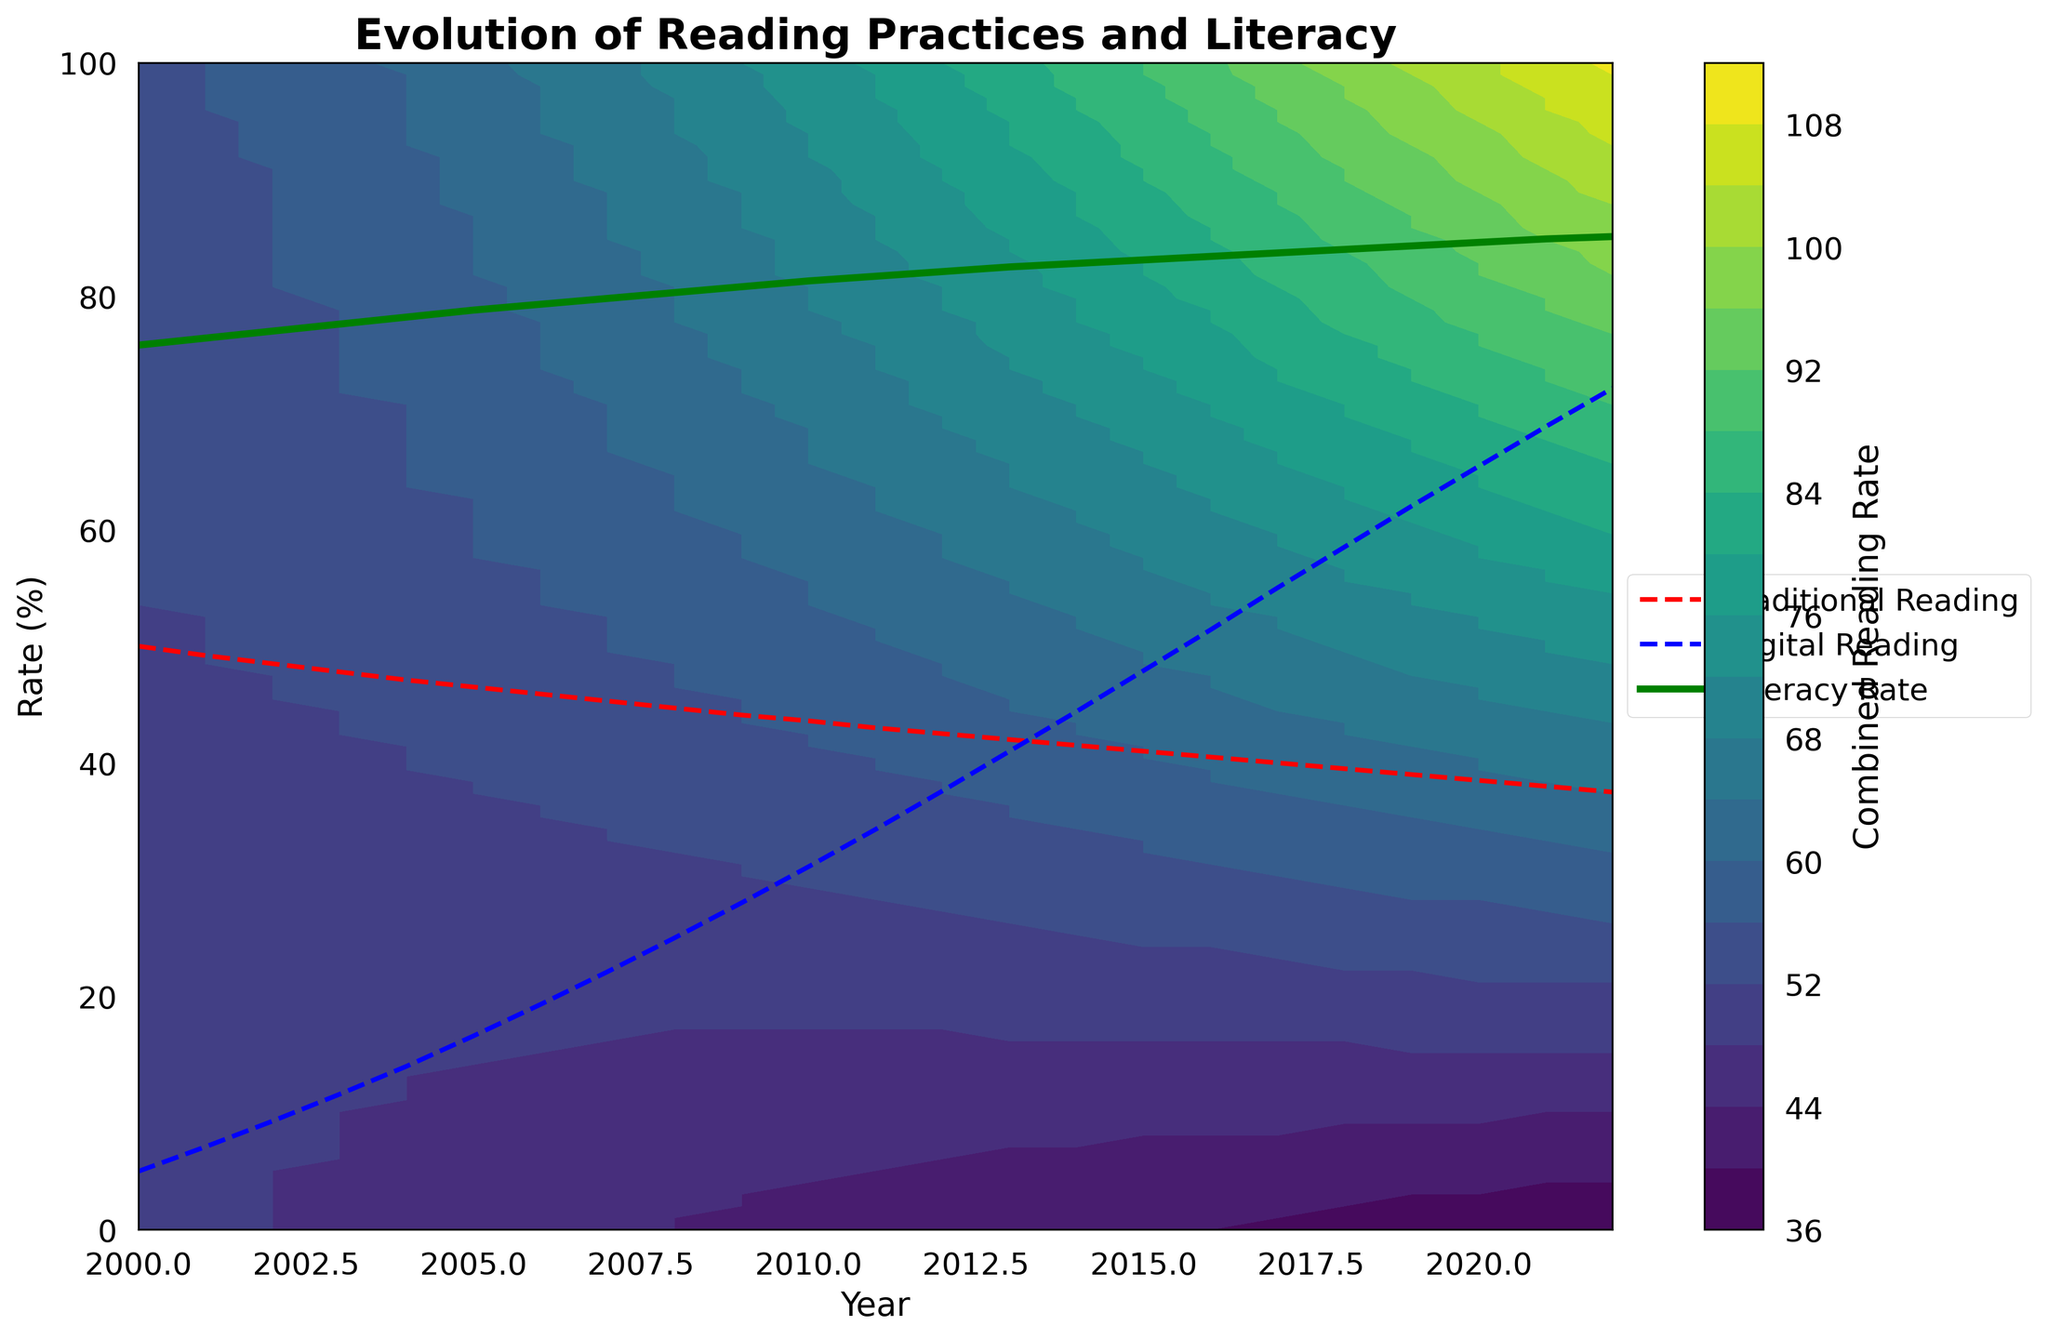What is the title of the plot? The title of the plot is "Evolution of Reading Practices and Literacy," which is prominently displayed at the top of the figure.
Answer: Evolution of Reading Practices and Literacy What are the x and y axes representing? The x-axis represents the years from 2000 to 2022, and the y-axis represents the rate in percentage from 0 to 100%. These axes provide the foundational framework for analyzing the trends presented in the plot.
Answer: Year, Rate (%) Which reading practice showed a consistent increase over the years? The blue dashed line on the plot represents the digital reading rate, which shows a consistent increase from 2000 to 2022. This observation can be made by following the trajectory of the blue dashed line.
Answer: Digital reading rate Which year shows the closest combined reading rate in traditional and digital reading practices? By examining the contour levels where traditional and digital reading rates seem to converge, we can note that around the year 2013 to 2014, both the lines representing traditional and digital reading practices appear to be closest.
Answer: 2013-2014 How did the literacy rate change from 2000 to 2022? The literacy rate, represented by the solid green line, shows a steady increase from roughly 75.8% in 2000 to about 85.1% in 2022. By tracing the green line from the left to the right, this trend is evident.
Answer: Increased steadily What is the difference in digital reading rate between the years 2000 and 2020? The digital reading rate in 2000 was approximately 5%, and in 2020 it was about 65.4%. The difference between these values is 65.4 - 5 = 60.4%.
Answer: 60.4% In what year does the literacy rate exceed 80%? By examining the green line representing the literacy rate, we can see that it exceeds 80% around the year 2009.
Answer: 2009 Which reading practice - traditional or digital - is represented by a red dashed line? The traditional reading rate is represented by the red dashed line, which can be identified by its trend decreasing over time.
Answer: Traditional reading rate Between which years did the literacy rate experience the most significant increase? The period between 2000 and 2022 shows a general increase, but if we look closely, the most significant slope in the green line representing the literacy rate appears to be between the years 2007 and 2012.
Answer: 2007-2012 How are the contour colors used in the plot? The contour colors, ranging from a lighter to a darker shade, represent the combined reading rate, with lighter shades indicating lower rates and darker shades indicating higher rates. These colors help visualize areas with different combined reading rates.
Answer: Indicate combined reading rate 